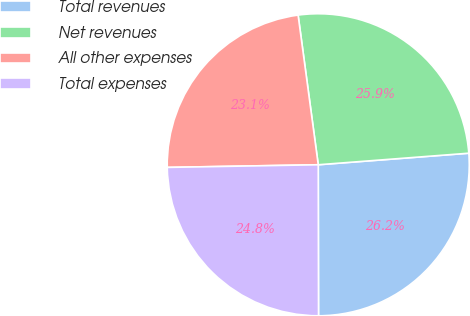<chart> <loc_0><loc_0><loc_500><loc_500><pie_chart><fcel>Total revenues<fcel>Net revenues<fcel>All other expenses<fcel>Total expenses<nl><fcel>26.19%<fcel>25.91%<fcel>23.15%<fcel>24.75%<nl></chart> 